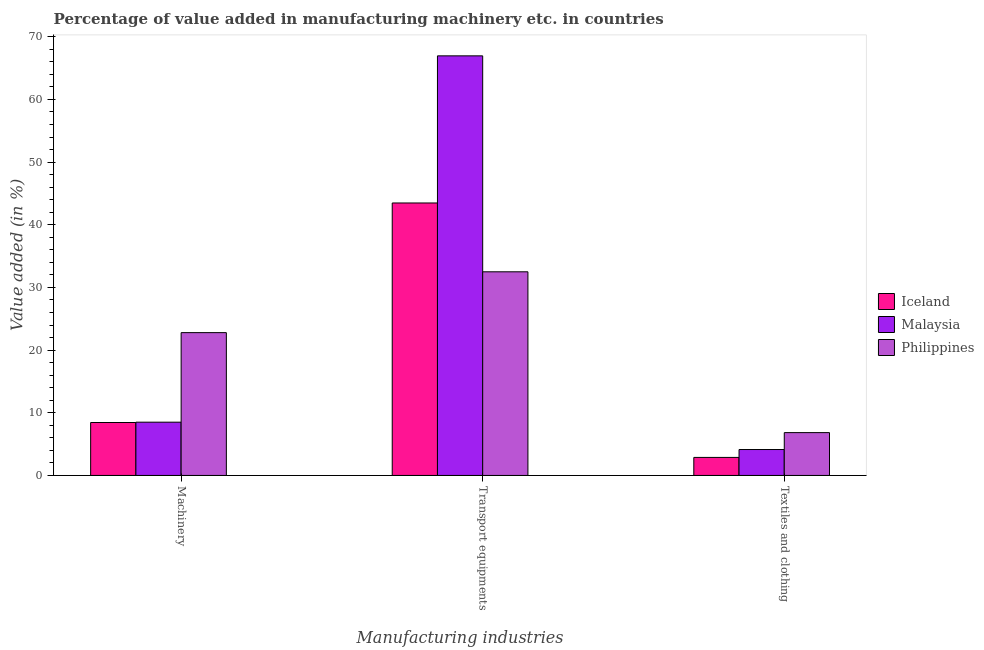How many different coloured bars are there?
Your answer should be very brief. 3. How many groups of bars are there?
Offer a terse response. 3. Are the number of bars per tick equal to the number of legend labels?
Make the answer very short. Yes. Are the number of bars on each tick of the X-axis equal?
Provide a short and direct response. Yes. What is the label of the 3rd group of bars from the left?
Provide a short and direct response. Textiles and clothing. What is the value added in manufacturing machinery in Philippines?
Your response must be concise. 22.79. Across all countries, what is the maximum value added in manufacturing transport equipments?
Make the answer very short. 66.95. Across all countries, what is the minimum value added in manufacturing textile and clothing?
Your answer should be compact. 2.88. What is the total value added in manufacturing textile and clothing in the graph?
Make the answer very short. 13.84. What is the difference between the value added in manufacturing transport equipments in Philippines and that in Malaysia?
Your answer should be very brief. -34.46. What is the difference between the value added in manufacturing transport equipments in Iceland and the value added in manufacturing machinery in Malaysia?
Your response must be concise. 34.98. What is the average value added in manufacturing transport equipments per country?
Provide a short and direct response. 47.64. What is the difference between the value added in manufacturing machinery and value added in manufacturing textile and clothing in Philippines?
Offer a very short reply. 15.95. In how many countries, is the value added in manufacturing machinery greater than 26 %?
Ensure brevity in your answer.  0. What is the ratio of the value added in manufacturing machinery in Iceland to that in Malaysia?
Offer a very short reply. 0.99. Is the difference between the value added in manufacturing machinery in Malaysia and Philippines greater than the difference between the value added in manufacturing transport equipments in Malaysia and Philippines?
Make the answer very short. No. What is the difference between the highest and the second highest value added in manufacturing transport equipments?
Offer a very short reply. 23.47. What is the difference between the highest and the lowest value added in manufacturing textile and clothing?
Provide a succinct answer. 3.96. What does the 2nd bar from the left in Machinery represents?
Your response must be concise. Malaysia. How many bars are there?
Ensure brevity in your answer.  9. What is the difference between two consecutive major ticks on the Y-axis?
Provide a succinct answer. 10. Are the values on the major ticks of Y-axis written in scientific E-notation?
Your answer should be compact. No. Does the graph contain any zero values?
Your answer should be very brief. No. What is the title of the graph?
Your answer should be very brief. Percentage of value added in manufacturing machinery etc. in countries. What is the label or title of the X-axis?
Offer a terse response. Manufacturing industries. What is the label or title of the Y-axis?
Make the answer very short. Value added (in %). What is the Value added (in %) of Iceland in Machinery?
Keep it short and to the point. 8.45. What is the Value added (in %) in Malaysia in Machinery?
Keep it short and to the point. 8.5. What is the Value added (in %) of Philippines in Machinery?
Your response must be concise. 22.79. What is the Value added (in %) of Iceland in Transport equipments?
Provide a short and direct response. 43.47. What is the Value added (in %) in Malaysia in Transport equipments?
Ensure brevity in your answer.  66.95. What is the Value added (in %) of Philippines in Transport equipments?
Offer a very short reply. 32.49. What is the Value added (in %) of Iceland in Textiles and clothing?
Your answer should be very brief. 2.88. What is the Value added (in %) of Malaysia in Textiles and clothing?
Offer a very short reply. 4.14. What is the Value added (in %) in Philippines in Textiles and clothing?
Your answer should be compact. 6.83. Across all Manufacturing industries, what is the maximum Value added (in %) of Iceland?
Provide a short and direct response. 43.47. Across all Manufacturing industries, what is the maximum Value added (in %) in Malaysia?
Provide a succinct answer. 66.95. Across all Manufacturing industries, what is the maximum Value added (in %) in Philippines?
Offer a terse response. 32.49. Across all Manufacturing industries, what is the minimum Value added (in %) in Iceland?
Make the answer very short. 2.88. Across all Manufacturing industries, what is the minimum Value added (in %) of Malaysia?
Offer a terse response. 4.14. Across all Manufacturing industries, what is the minimum Value added (in %) of Philippines?
Ensure brevity in your answer.  6.83. What is the total Value added (in %) in Iceland in the graph?
Ensure brevity in your answer.  54.79. What is the total Value added (in %) in Malaysia in the graph?
Your answer should be compact. 79.58. What is the total Value added (in %) of Philippines in the graph?
Ensure brevity in your answer.  62.11. What is the difference between the Value added (in %) of Iceland in Machinery and that in Transport equipments?
Offer a terse response. -35.03. What is the difference between the Value added (in %) of Malaysia in Machinery and that in Transport equipments?
Provide a short and direct response. -58.45. What is the difference between the Value added (in %) of Philippines in Machinery and that in Transport equipments?
Your answer should be compact. -9.71. What is the difference between the Value added (in %) of Iceland in Machinery and that in Textiles and clothing?
Offer a very short reply. 5.57. What is the difference between the Value added (in %) in Malaysia in Machinery and that in Textiles and clothing?
Your answer should be very brief. 4.36. What is the difference between the Value added (in %) in Philippines in Machinery and that in Textiles and clothing?
Keep it short and to the point. 15.95. What is the difference between the Value added (in %) in Iceland in Transport equipments and that in Textiles and clothing?
Your answer should be very brief. 40.6. What is the difference between the Value added (in %) of Malaysia in Transport equipments and that in Textiles and clothing?
Make the answer very short. 62.81. What is the difference between the Value added (in %) of Philippines in Transport equipments and that in Textiles and clothing?
Provide a short and direct response. 25.66. What is the difference between the Value added (in %) of Iceland in Machinery and the Value added (in %) of Malaysia in Transport equipments?
Offer a terse response. -58.5. What is the difference between the Value added (in %) in Iceland in Machinery and the Value added (in %) in Philippines in Transport equipments?
Ensure brevity in your answer.  -24.05. What is the difference between the Value added (in %) of Malaysia in Machinery and the Value added (in %) of Philippines in Transport equipments?
Keep it short and to the point. -23.99. What is the difference between the Value added (in %) of Iceland in Machinery and the Value added (in %) of Malaysia in Textiles and clothing?
Your answer should be compact. 4.31. What is the difference between the Value added (in %) in Iceland in Machinery and the Value added (in %) in Philippines in Textiles and clothing?
Your response must be concise. 1.61. What is the difference between the Value added (in %) of Malaysia in Machinery and the Value added (in %) of Philippines in Textiles and clothing?
Keep it short and to the point. 1.67. What is the difference between the Value added (in %) of Iceland in Transport equipments and the Value added (in %) of Malaysia in Textiles and clothing?
Offer a very short reply. 39.34. What is the difference between the Value added (in %) in Iceland in Transport equipments and the Value added (in %) in Philippines in Textiles and clothing?
Your response must be concise. 36.64. What is the difference between the Value added (in %) in Malaysia in Transport equipments and the Value added (in %) in Philippines in Textiles and clothing?
Keep it short and to the point. 60.12. What is the average Value added (in %) of Iceland per Manufacturing industries?
Provide a short and direct response. 18.26. What is the average Value added (in %) in Malaysia per Manufacturing industries?
Your response must be concise. 26.53. What is the average Value added (in %) of Philippines per Manufacturing industries?
Offer a terse response. 20.7. What is the difference between the Value added (in %) in Iceland and Value added (in %) in Malaysia in Machinery?
Ensure brevity in your answer.  -0.05. What is the difference between the Value added (in %) in Iceland and Value added (in %) in Philippines in Machinery?
Offer a very short reply. -14.34. What is the difference between the Value added (in %) of Malaysia and Value added (in %) of Philippines in Machinery?
Provide a succinct answer. -14.29. What is the difference between the Value added (in %) in Iceland and Value added (in %) in Malaysia in Transport equipments?
Provide a short and direct response. -23.47. What is the difference between the Value added (in %) in Iceland and Value added (in %) in Philippines in Transport equipments?
Ensure brevity in your answer.  10.98. What is the difference between the Value added (in %) of Malaysia and Value added (in %) of Philippines in Transport equipments?
Your answer should be very brief. 34.46. What is the difference between the Value added (in %) in Iceland and Value added (in %) in Malaysia in Textiles and clothing?
Offer a very short reply. -1.26. What is the difference between the Value added (in %) in Iceland and Value added (in %) in Philippines in Textiles and clothing?
Your response must be concise. -3.96. What is the difference between the Value added (in %) in Malaysia and Value added (in %) in Philippines in Textiles and clothing?
Your answer should be very brief. -2.7. What is the ratio of the Value added (in %) in Iceland in Machinery to that in Transport equipments?
Provide a succinct answer. 0.19. What is the ratio of the Value added (in %) of Malaysia in Machinery to that in Transport equipments?
Your response must be concise. 0.13. What is the ratio of the Value added (in %) in Philippines in Machinery to that in Transport equipments?
Provide a succinct answer. 0.7. What is the ratio of the Value added (in %) in Iceland in Machinery to that in Textiles and clothing?
Your response must be concise. 2.94. What is the ratio of the Value added (in %) of Malaysia in Machinery to that in Textiles and clothing?
Your answer should be compact. 2.05. What is the ratio of the Value added (in %) of Philippines in Machinery to that in Textiles and clothing?
Your answer should be compact. 3.33. What is the ratio of the Value added (in %) in Iceland in Transport equipments to that in Textiles and clothing?
Your answer should be very brief. 15.12. What is the ratio of the Value added (in %) of Malaysia in Transport equipments to that in Textiles and clothing?
Your answer should be very brief. 16.19. What is the ratio of the Value added (in %) of Philippines in Transport equipments to that in Textiles and clothing?
Keep it short and to the point. 4.76. What is the difference between the highest and the second highest Value added (in %) of Iceland?
Keep it short and to the point. 35.03. What is the difference between the highest and the second highest Value added (in %) in Malaysia?
Make the answer very short. 58.45. What is the difference between the highest and the second highest Value added (in %) of Philippines?
Provide a succinct answer. 9.71. What is the difference between the highest and the lowest Value added (in %) of Iceland?
Make the answer very short. 40.6. What is the difference between the highest and the lowest Value added (in %) of Malaysia?
Offer a terse response. 62.81. What is the difference between the highest and the lowest Value added (in %) in Philippines?
Your answer should be very brief. 25.66. 